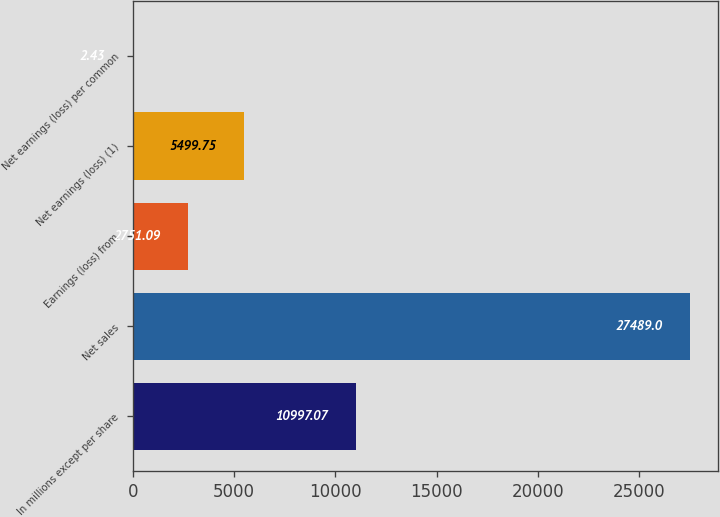<chart> <loc_0><loc_0><loc_500><loc_500><bar_chart><fcel>In millions except per share<fcel>Net sales<fcel>Earnings (loss) from<fcel>Net earnings (loss) (1)<fcel>Net earnings (loss) per common<nl><fcel>10997.1<fcel>27489<fcel>2751.09<fcel>5499.75<fcel>2.43<nl></chart> 